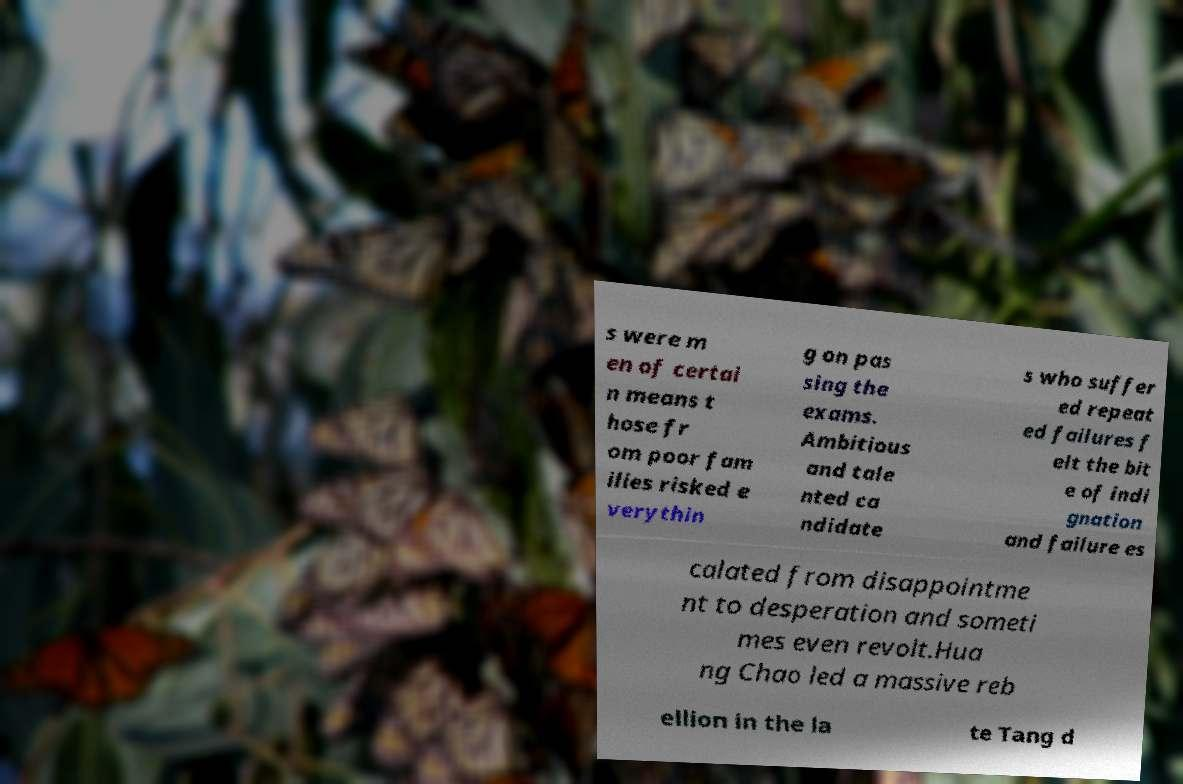What messages or text are displayed in this image? I need them in a readable, typed format. s were m en of certai n means t hose fr om poor fam ilies risked e verythin g on pas sing the exams. Ambitious and tale nted ca ndidate s who suffer ed repeat ed failures f elt the bit e of indi gnation and failure es calated from disappointme nt to desperation and someti mes even revolt.Hua ng Chao led a massive reb ellion in the la te Tang d 